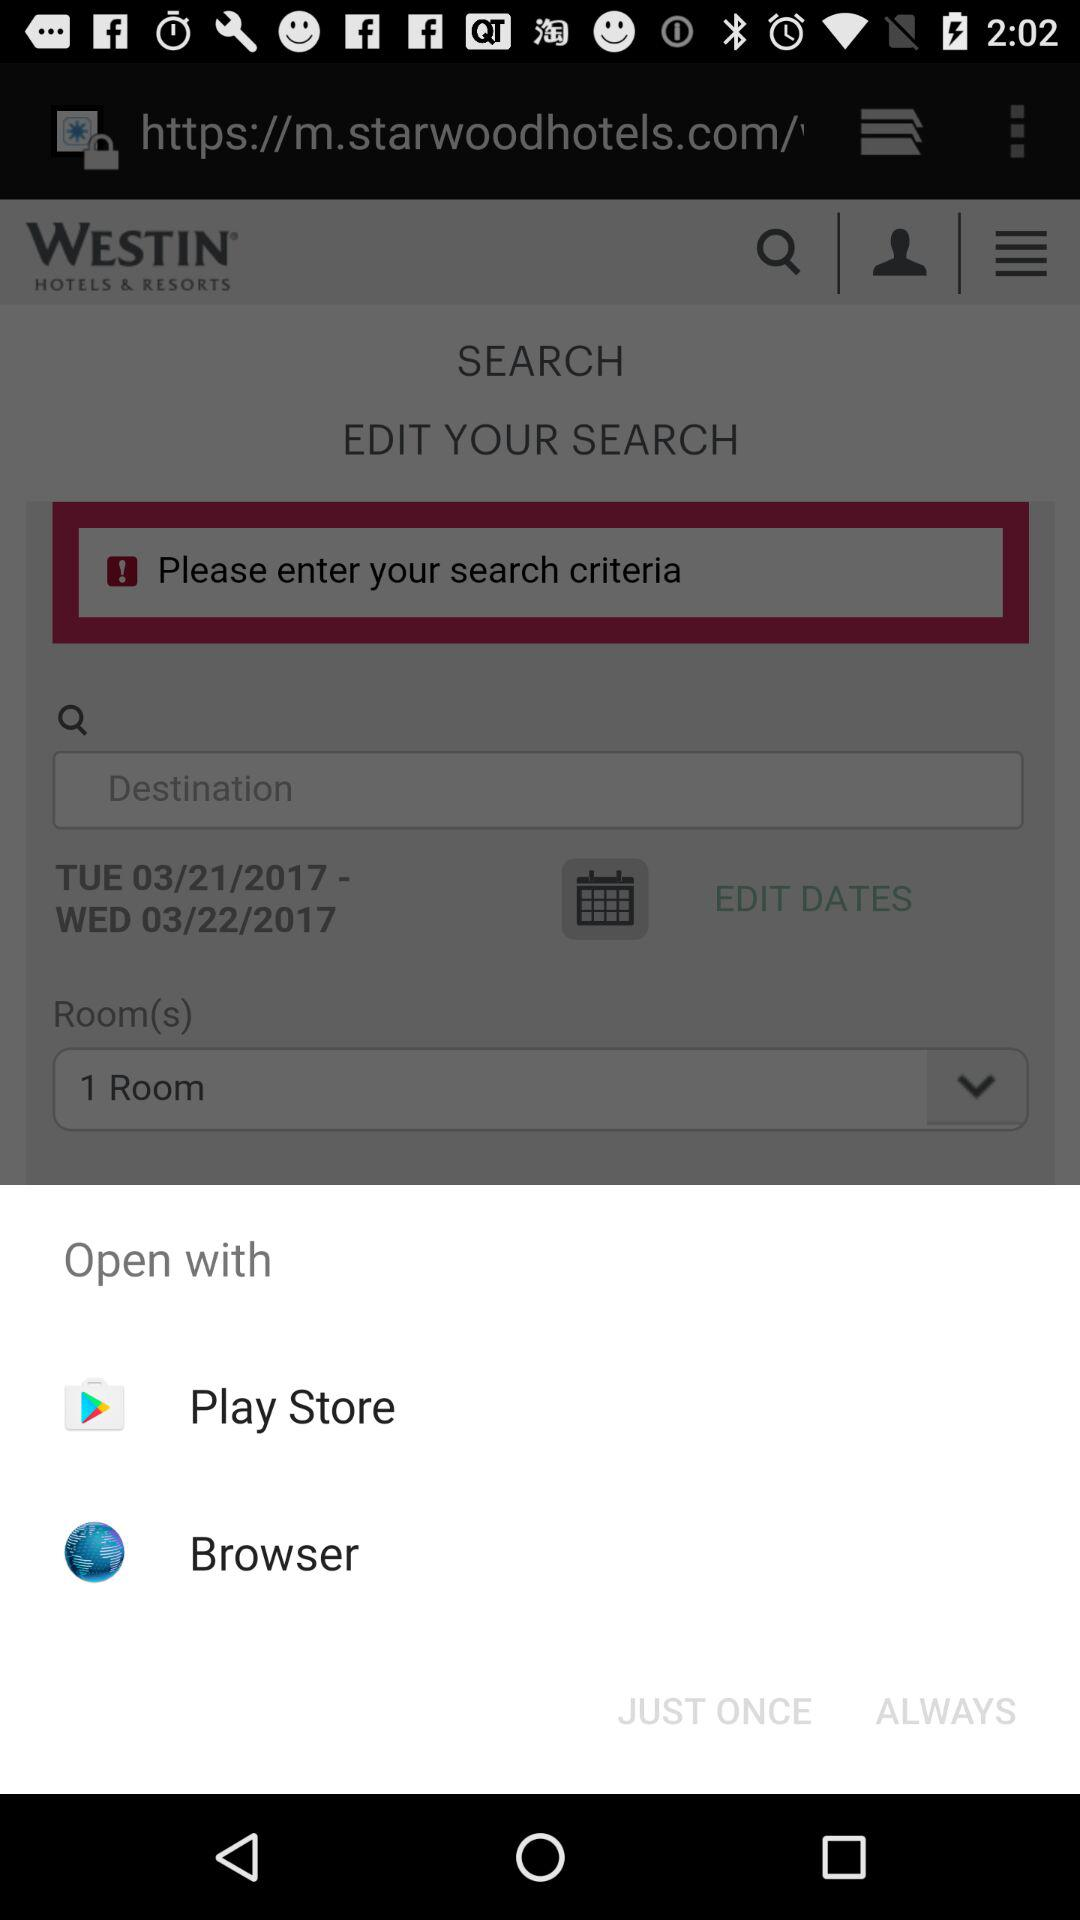How many options are available for opening the app?
Answer the question using a single word or phrase. 2 